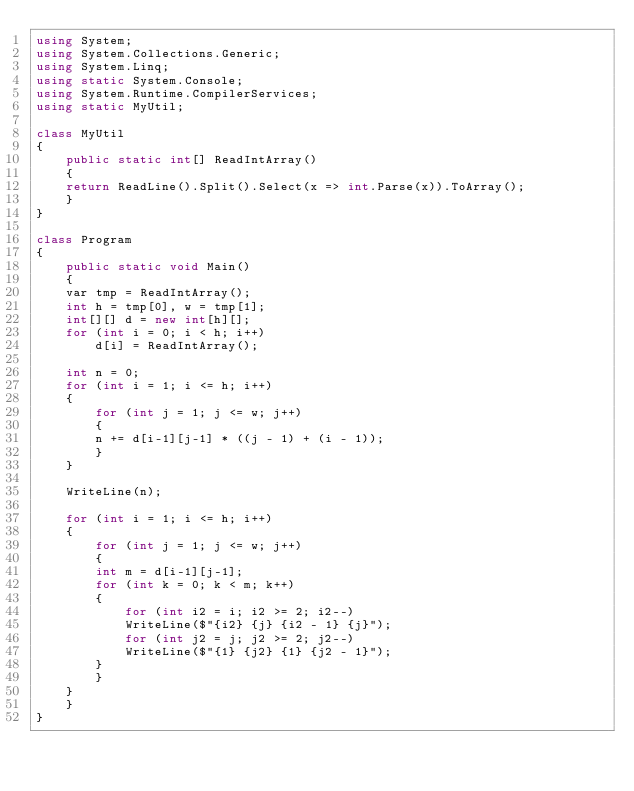Convert code to text. <code><loc_0><loc_0><loc_500><loc_500><_C#_>using System;
using System.Collections.Generic;
using System.Linq;
using static System.Console;
using System.Runtime.CompilerServices;
using static MyUtil;

class MyUtil
{
    public static int[] ReadIntArray()
    {
	return ReadLine().Split().Select(x => int.Parse(x)).ToArray();
    }
}

class Program
{
    public static void Main()
    {
	var tmp = ReadIntArray();
	int h = tmp[0], w = tmp[1];
	int[][] d = new int[h][];
	for (int i = 0; i < h; i++)
	    d[i] = ReadIntArray();

	int n = 0;
	for (int i = 1; i <= h; i++)
	{
	    for (int j = 1; j <= w; j++)
	    {
		n += d[i-1][j-1] * ((j - 1) + (i - 1));
	    }
	}

	WriteLine(n);

	for (int i = 1; i <= h; i++)
	{
	    for (int j = 1; j <= w; j++)
	    {
		int m = d[i-1][j-1];
		for (int k = 0; k < m; k++)
		{
		    for (int i2 = i; i2 >= 2; i2--)
			WriteLine($"{i2} {j} {i2 - 1} {j}");
		    for (int j2 = j; j2 >= 2; j2--)
			WriteLine($"{1} {j2} {1} {j2 - 1}");
		}
	    }
	}
    }
}
</code> 